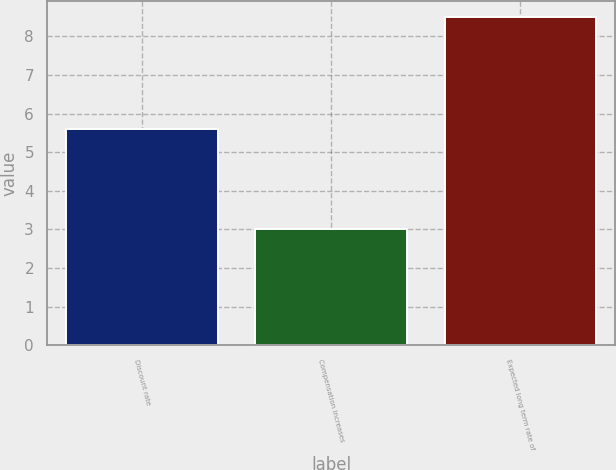<chart> <loc_0><loc_0><loc_500><loc_500><bar_chart><fcel>Discount rate<fcel>Compensation increases<fcel>Expected long term rate of<nl><fcel>5.6<fcel>3<fcel>8.5<nl></chart> 